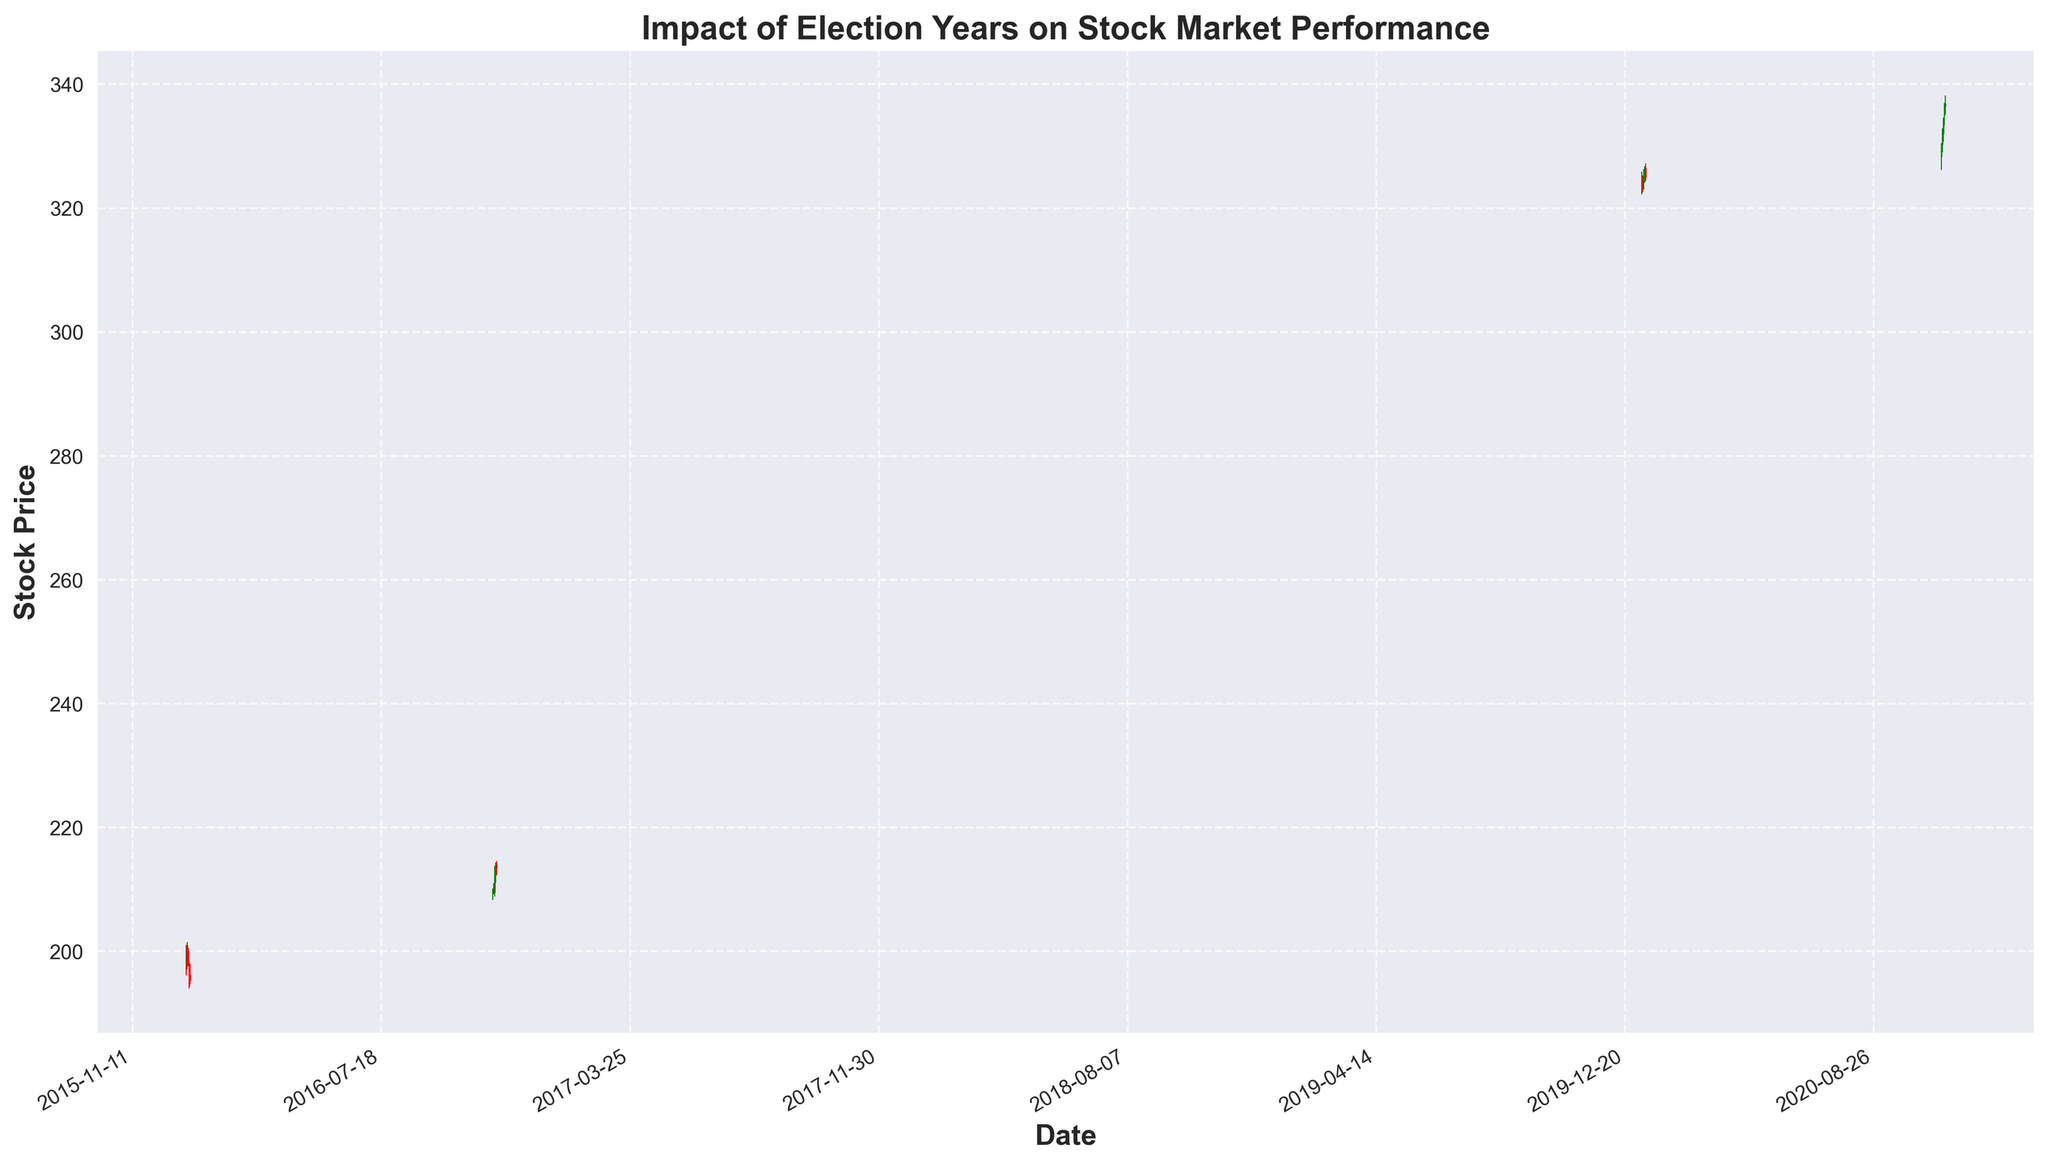What are the opening and closing prices of the stock on November 7, 2016? The plot shows the stock prices on various dates. According to the data from the figure, on November 7, 2016, the opening price is 209.41, and the closing price is 210.10.
Answer: Opening: 209.41, Closing: 210.10 Which date in November 2020 shows the highest closing price, and what is that price? From the figure, inspect the closing prices for each day in November 2020. The highest closing price is on November 6, 2020, with a closing price of 336.90.
Answer: November 6, 2020, 336.90 Compare the stock price movements during the first week of January in the 2016 and 2020 election years. How do they differ? In the 2016 election year, the stock price started around 199.47 on January 4 and showed a closing price trend downward by the end of the first week. Conversely, in 2020, the stock price started at 323.31 on January 6 and exhibited an upward closing trend by the end of the first week.
Answer: 2016: downward, 2020: upward What is the average closing price of the stock during the week of November 3-7, 2020? Extract the closing prices from November 3 to November 7, 2020 (331.50, 333.62, 335.92, 336.90). Calculate the average by summing them up and dividing by the number of days: (331.50 + 333.62 + 335.92 + 336.90) / 4 = 334.99.
Answer: 334.99 Which Green candlestick showing a price increase appears highest in the November 2020 election week? Green candlesticks represent days the stock closed higher than it opened. The tallest green candlestick within November 3-7, 2020, appears to be on November 5, indicating the highest price increase with closing at 335.92.
Answer: November 5, 2020 